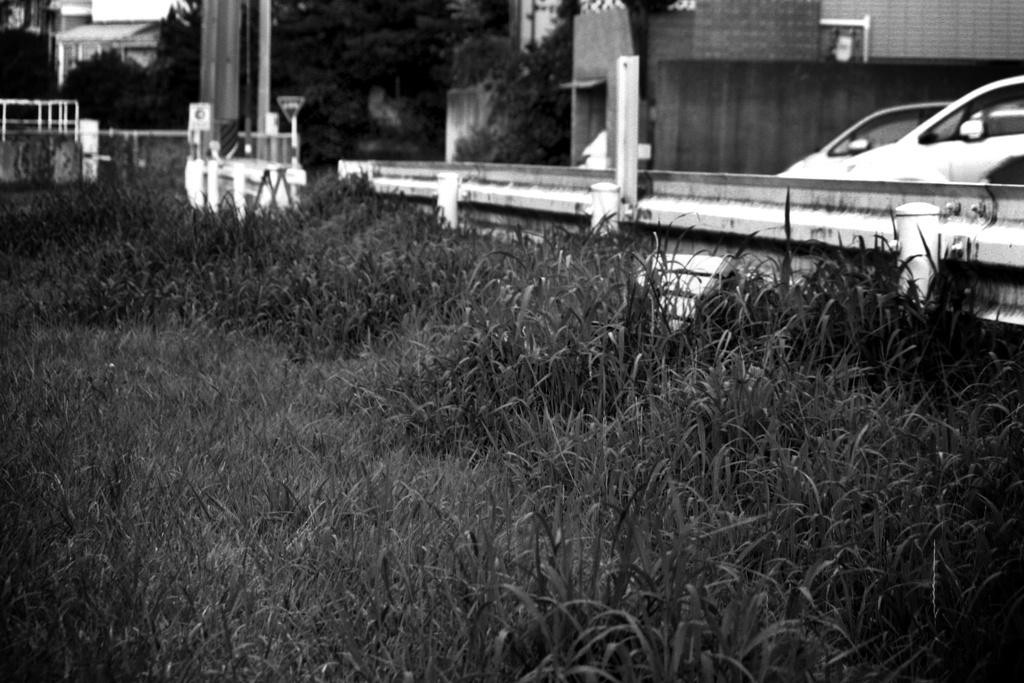What type of vegetation is present in the image? There is grass in the image. What type of vehicles can be seen in the image? There are cars in the image. What can be seen in the background of the image? There is a wall, trees, and the sky visible in the background of the image. What type of sail can be seen on the road in the image? There is no sail or road present in the image. How many trucks are visible in the image? There are no trucks visible in the image. 